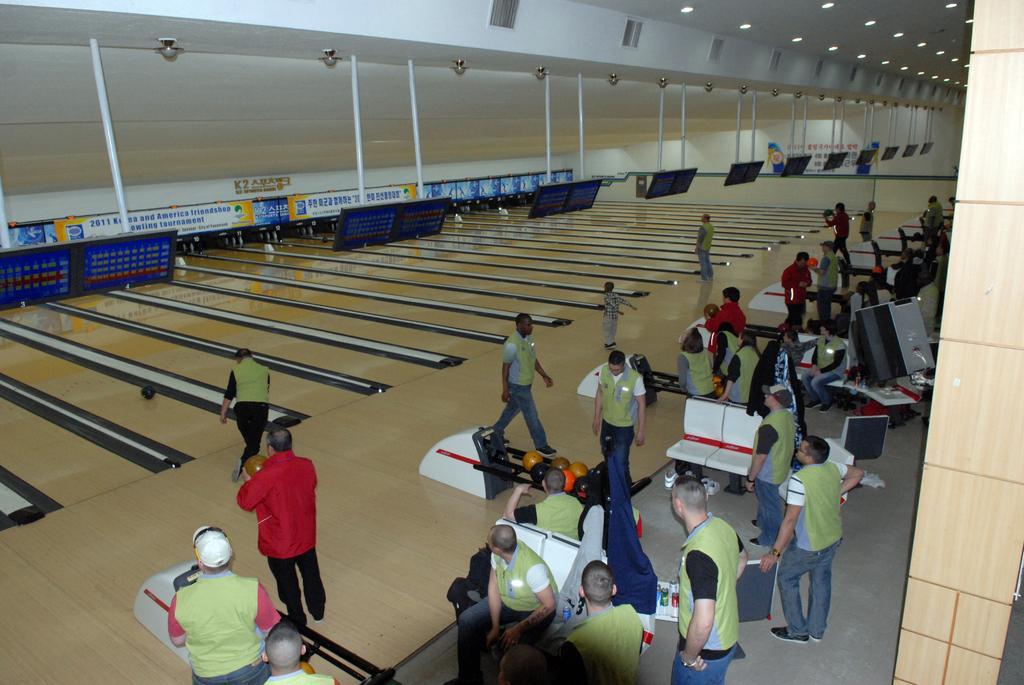Please provide a concise description of this image. In this image we can see group of persons wearing dress are standing on the floor, some persons are sitting and some are holding balls in their hands. In the center of the image we can see some screens on stands, some lights. In the background, we can see sign boards with some text and speakers. 